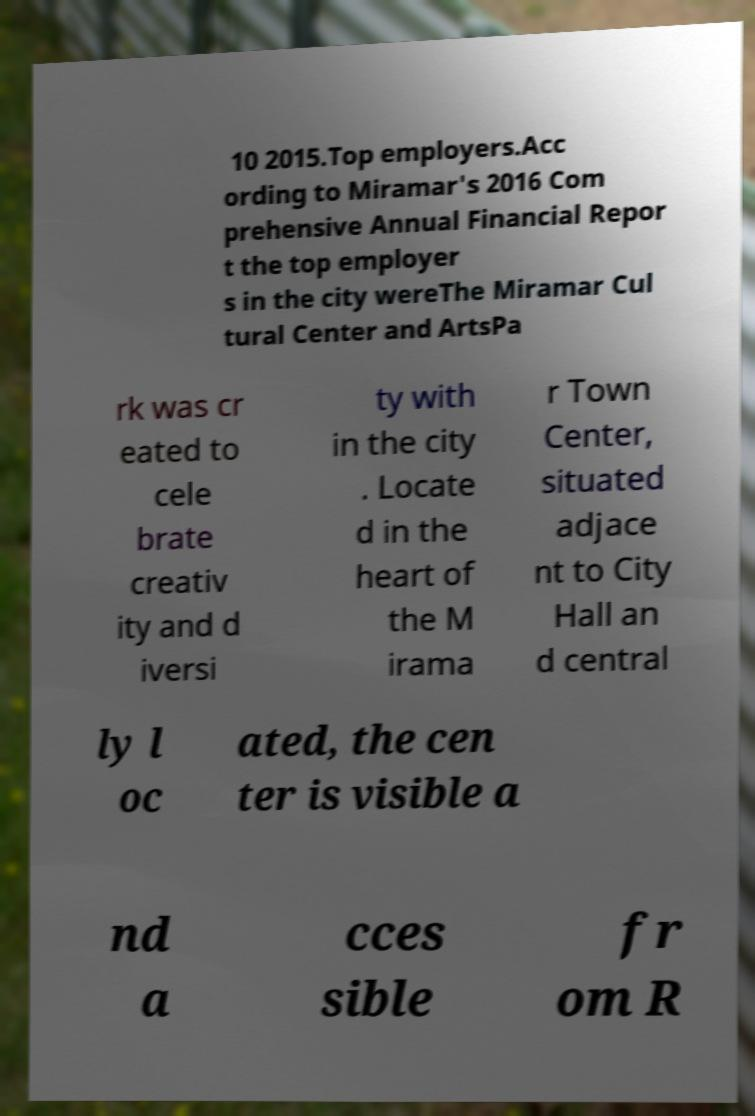Can you read and provide the text displayed in the image?This photo seems to have some interesting text. Can you extract and type it out for me? 10 2015.Top employers.Acc ording to Miramar's 2016 Com prehensive Annual Financial Repor t the top employer s in the city wereThe Miramar Cul tural Center and ArtsPa rk was cr eated to cele brate creativ ity and d iversi ty with in the city . Locate d in the heart of the M irama r Town Center, situated adjace nt to City Hall an d central ly l oc ated, the cen ter is visible a nd a cces sible fr om R 